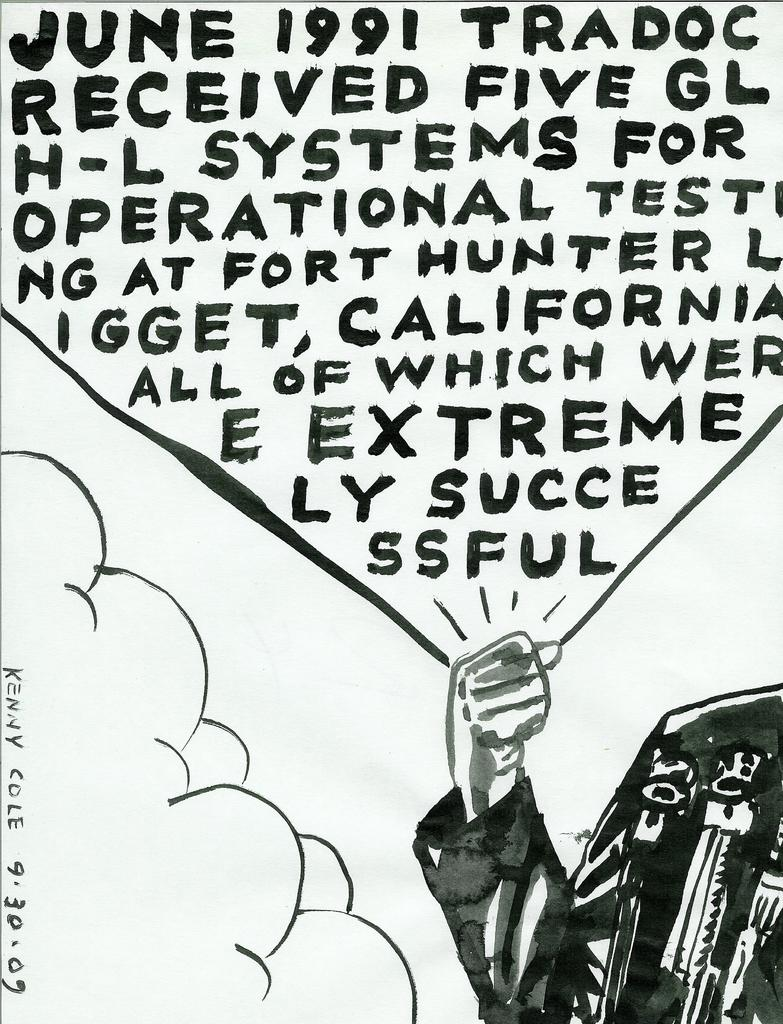What can be seen in the image related to a person's body part? There is a person's hand in the image. What is written on the paper in the image? There is text written on a paper in the image. What type of toy can be seen on fire in the image? There is no toy or fire present in the image. 